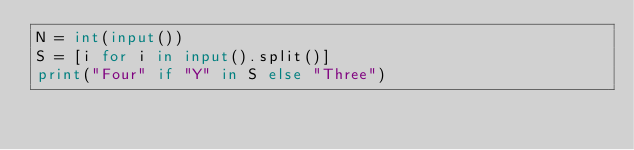Convert code to text. <code><loc_0><loc_0><loc_500><loc_500><_Python_>N = int(input())
S = [i for i in input().split()]
print("Four" if "Y" in S else "Three")</code> 